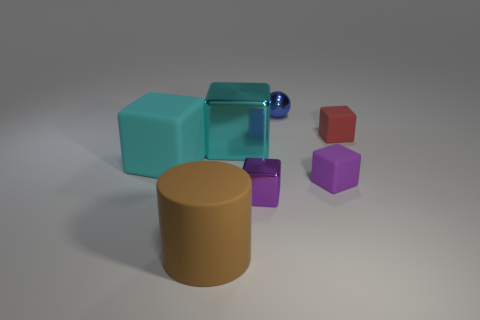What is the material of the thing that is the same color as the big shiny cube?
Offer a terse response. Rubber. What number of objects are cubes that are on the left side of the purple metallic cube or tiny red rubber objects that are on the right side of the brown cylinder?
Your response must be concise. 3. Do the brown thing that is in front of the large cyan matte block and the purple rubber object behind the brown thing have the same size?
Make the answer very short. No. The tiny shiny thing that is the same shape as the large cyan rubber object is what color?
Give a very brief answer. Purple. Is there anything else that is the same shape as the small blue thing?
Your answer should be very brief. No. Are there more objects behind the small purple matte cube than matte things that are in front of the brown object?
Your answer should be compact. Yes. There is a matte object in front of the small matte thing that is in front of the cyan thing that is right of the large cyan rubber object; how big is it?
Provide a short and direct response. Large. Is the red object made of the same material as the big object in front of the large cyan matte thing?
Make the answer very short. Yes. Is the shape of the tiny purple metal object the same as the tiny red matte object?
Your answer should be compact. Yes. What number of other objects are the same material as the tiny red object?
Make the answer very short. 3. 